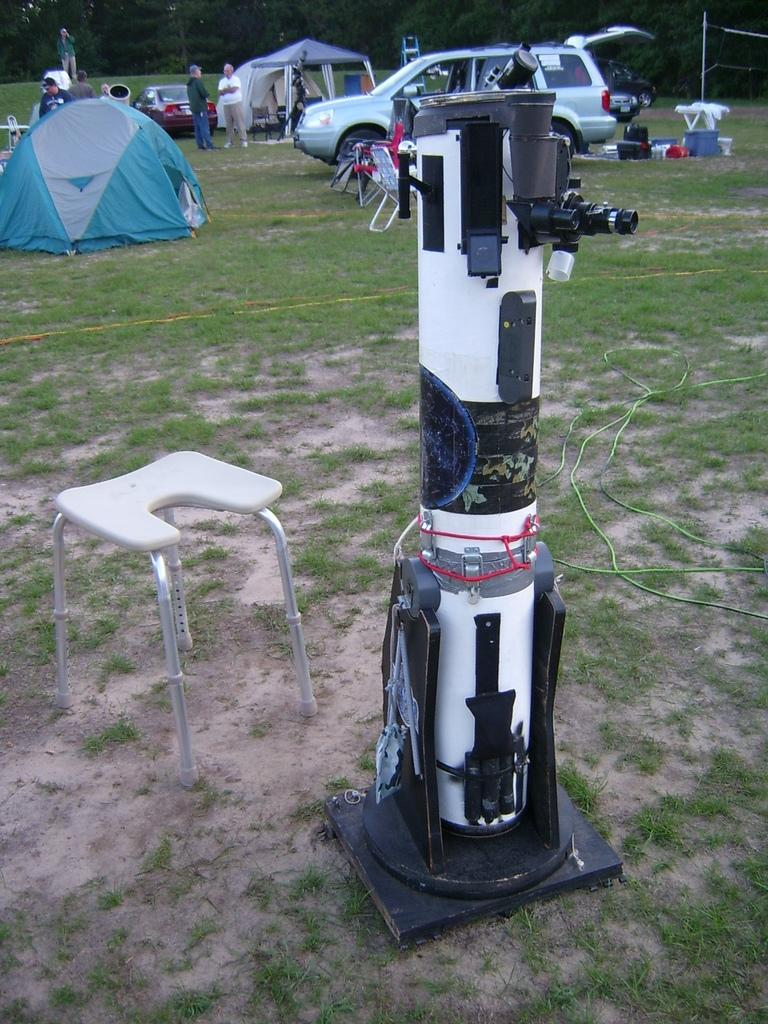What type of temporary shelters can be seen in the image? There are tents in the image. What type of vehicles are present in the image? There are cars in the image. What type of ground surface is visible in the image? There is grass in the image. What type of seating is available in the image? There are chairs in the image. How many people can be seen in the image? There are persons in the image. What type of electronic device is present in the image? There is a device in the image. What type of natural scenery is visible in the background of the image? There are trees in the background of the image. How many bulbs are hanging from the trees in the image? There are no bulbs present in the image; it features tents, cars, grass, chairs, persons, and a device. What type of shape is formed by the arrangement of the tents in the image? The arrangement of the tents in the image does not form a specific shape like a circle. 